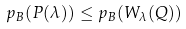<formula> <loc_0><loc_0><loc_500><loc_500>p _ { B } ( P ( \lambda ) ) \leq p _ { B } ( W _ { \lambda } ( Q ) )</formula> 